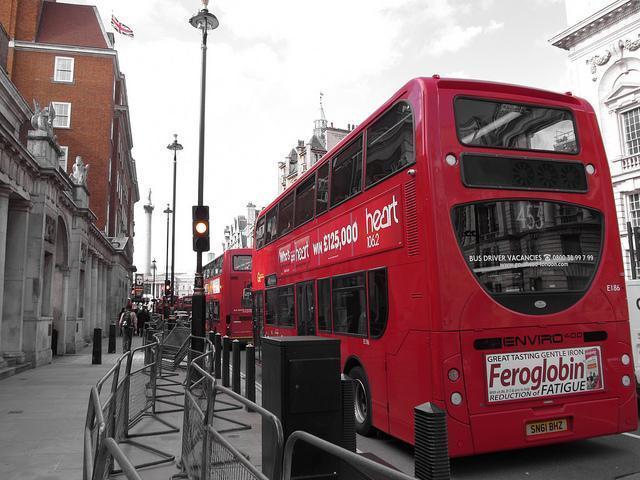How many sets of stairs are visible?
Give a very brief answer. 0. How many buses are in the photo?
Give a very brief answer. 2. 